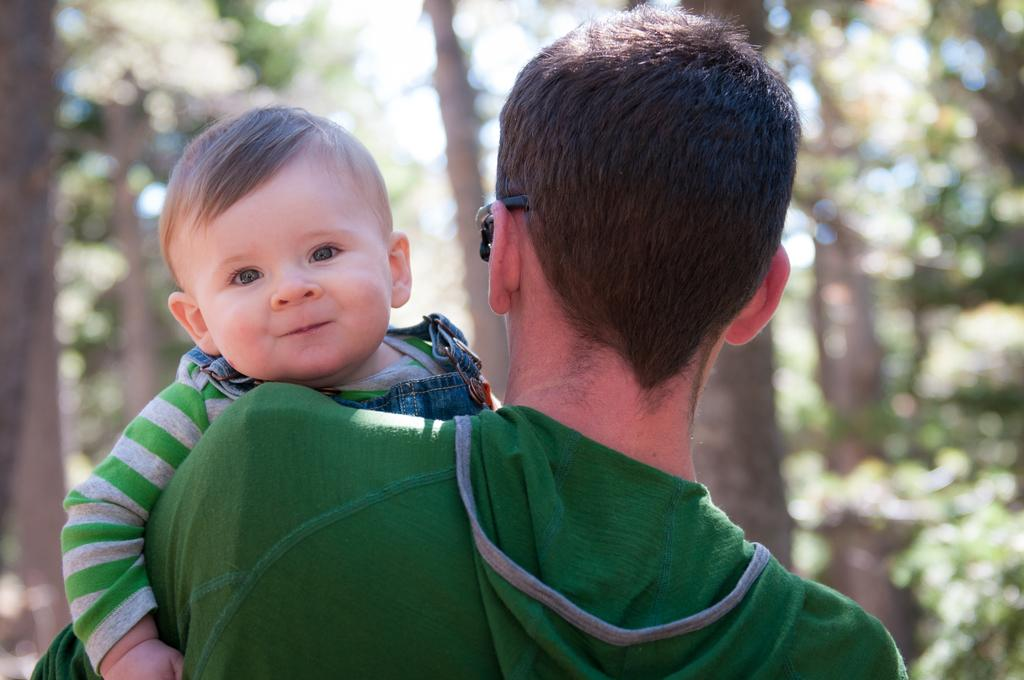What is the person in the image doing? The person is holding a baby in the image. What can be seen in the background of the image? There is light and greenery in the background of the image. What type of hole can be seen in the ground in the image? There is no hole present in the ground in the image. What kind of apple is being held by the person in the image? There is no apple present in the image; the person is holding a baby. 